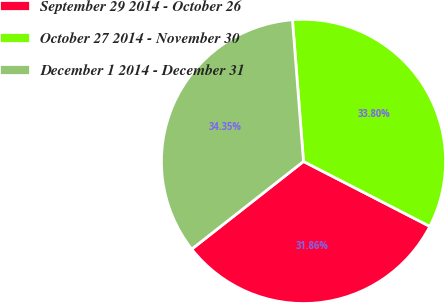Convert chart. <chart><loc_0><loc_0><loc_500><loc_500><pie_chart><fcel>September 29 2014 - October 26<fcel>October 27 2014 - November 30<fcel>December 1 2014 - December 31<nl><fcel>31.86%<fcel>33.8%<fcel>34.35%<nl></chart> 